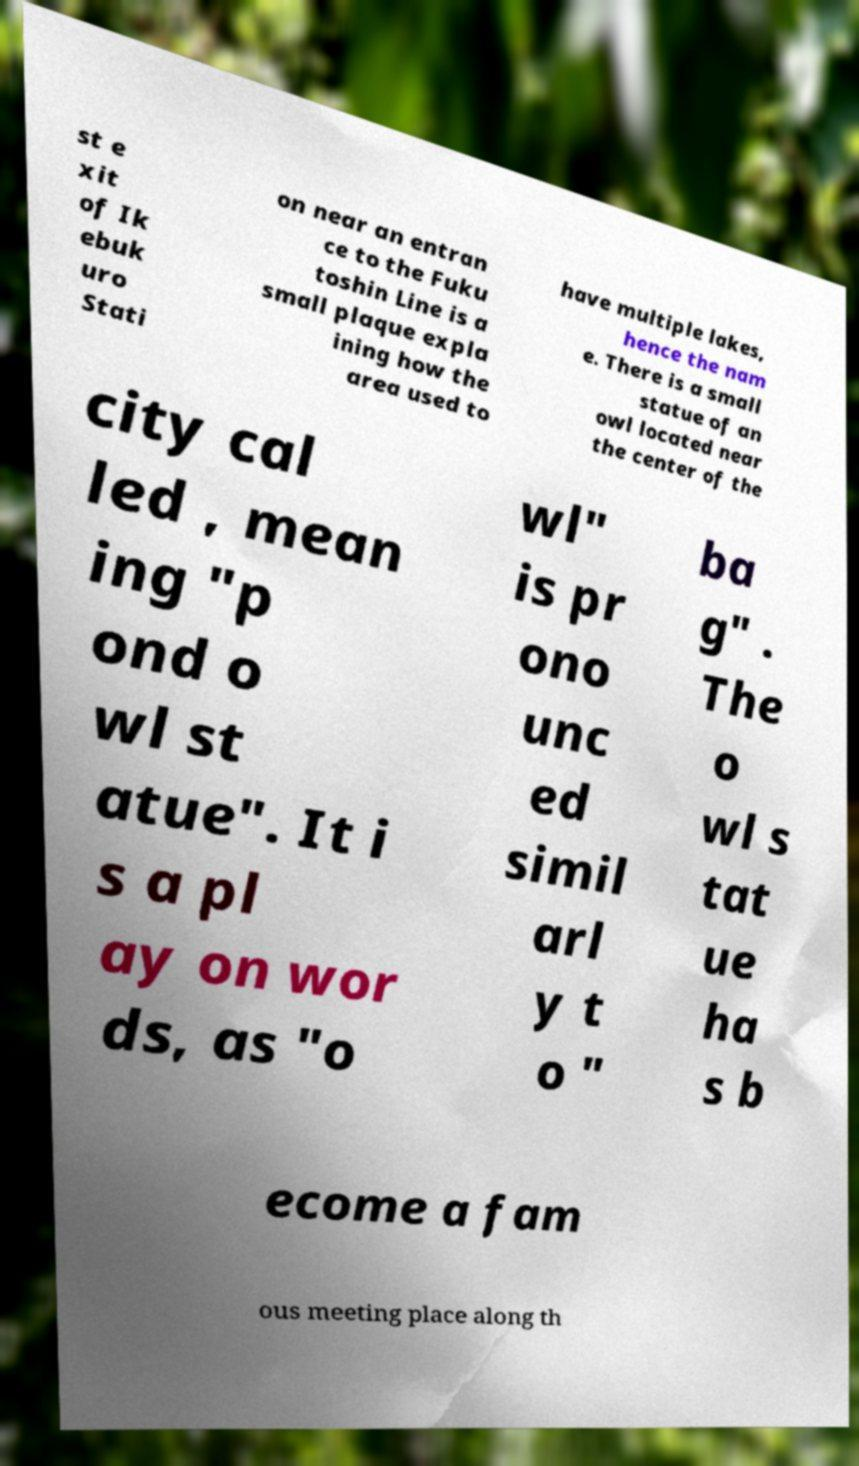Please identify and transcribe the text found in this image. st e xit of Ik ebuk uro Stati on near an entran ce to the Fuku toshin Line is a small plaque expla ining how the area used to have multiple lakes, hence the nam e. There is a small statue of an owl located near the center of the city cal led , mean ing "p ond o wl st atue". It i s a pl ay on wor ds, as "o wl" is pr ono unc ed simil arl y t o " ba g" . The o wl s tat ue ha s b ecome a fam ous meeting place along th 